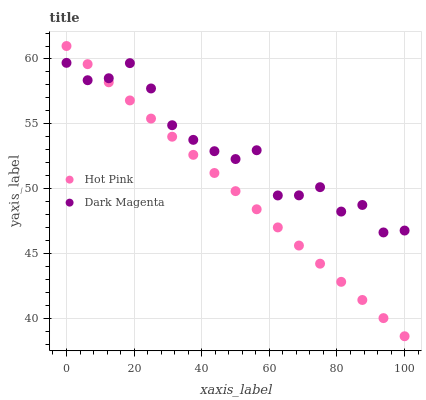Does Hot Pink have the minimum area under the curve?
Answer yes or no. Yes. Does Dark Magenta have the maximum area under the curve?
Answer yes or no. Yes. Does Dark Magenta have the minimum area under the curve?
Answer yes or no. No. Is Hot Pink the smoothest?
Answer yes or no. Yes. Is Dark Magenta the roughest?
Answer yes or no. Yes. Is Dark Magenta the smoothest?
Answer yes or no. No. Does Hot Pink have the lowest value?
Answer yes or no. Yes. Does Dark Magenta have the lowest value?
Answer yes or no. No. Does Hot Pink have the highest value?
Answer yes or no. Yes. Does Dark Magenta have the highest value?
Answer yes or no. No. Does Hot Pink intersect Dark Magenta?
Answer yes or no. Yes. Is Hot Pink less than Dark Magenta?
Answer yes or no. No. Is Hot Pink greater than Dark Magenta?
Answer yes or no. No. 